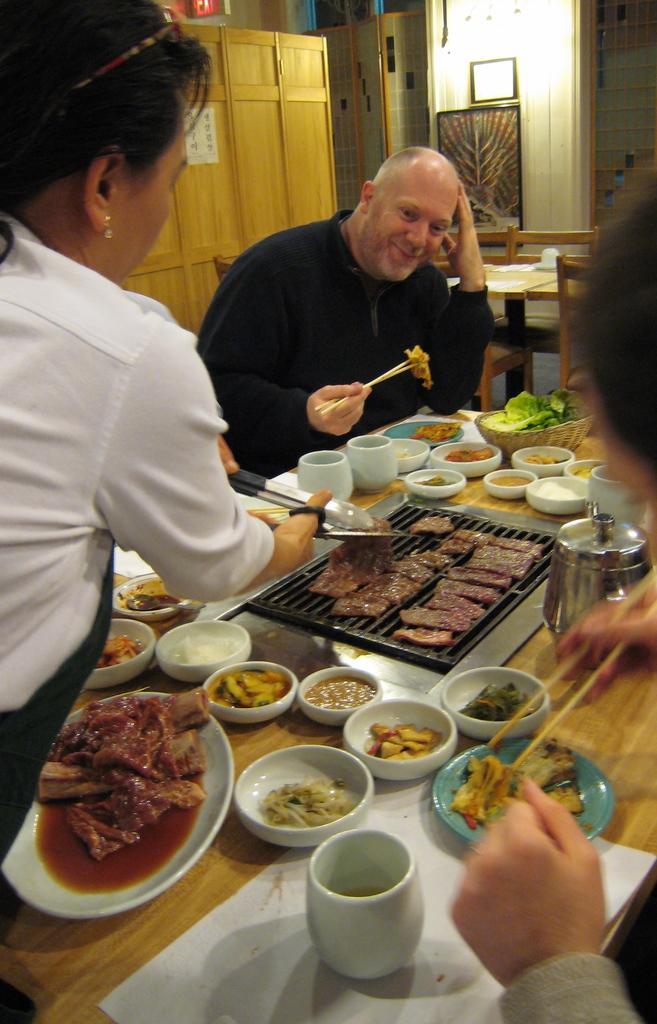How would you summarize this image in a sentence or two? In this image I can see few people and I can see two of them are holding chopsticks. I can also see smile on his face and here on this table I can see food in bowls and in plates. I can also see few white color cups. In the background I can see few chairs and a frame on wall. 